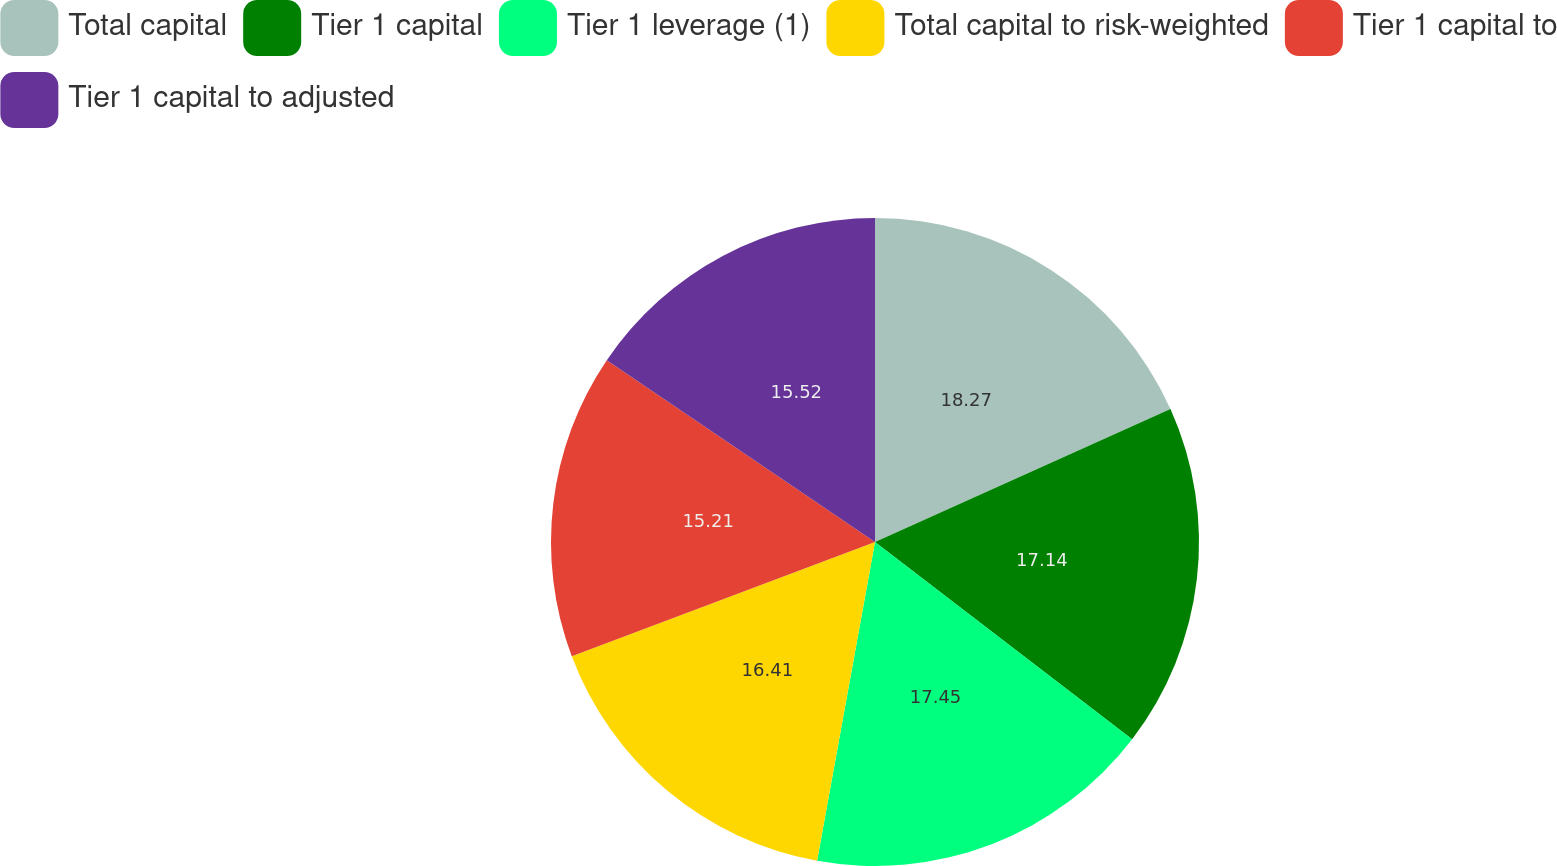Convert chart to OTSL. <chart><loc_0><loc_0><loc_500><loc_500><pie_chart><fcel>Total capital<fcel>Tier 1 capital<fcel>Tier 1 leverage (1)<fcel>Total capital to risk-weighted<fcel>Tier 1 capital to<fcel>Tier 1 capital to adjusted<nl><fcel>18.27%<fcel>17.14%<fcel>17.45%<fcel>16.41%<fcel>15.21%<fcel>15.52%<nl></chart> 